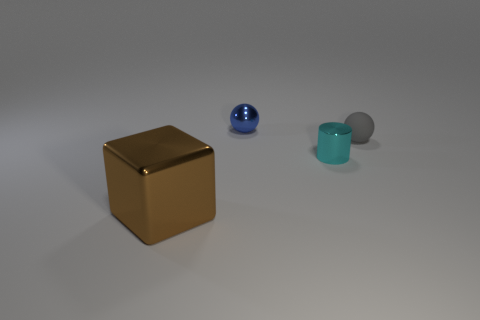Add 4 large blocks. How many objects exist? 8 Subtract all blue spheres. How many spheres are left? 1 Subtract 2 balls. How many balls are left? 0 Subtract all cyan cylinders. How many blue spheres are left? 1 Add 4 blue spheres. How many blue spheres are left? 5 Add 3 big cubes. How many big cubes exist? 4 Subtract 1 brown blocks. How many objects are left? 3 Subtract all blocks. How many objects are left? 3 Subtract all blue balls. Subtract all blue blocks. How many balls are left? 1 Subtract all big brown blocks. Subtract all small shiny things. How many objects are left? 1 